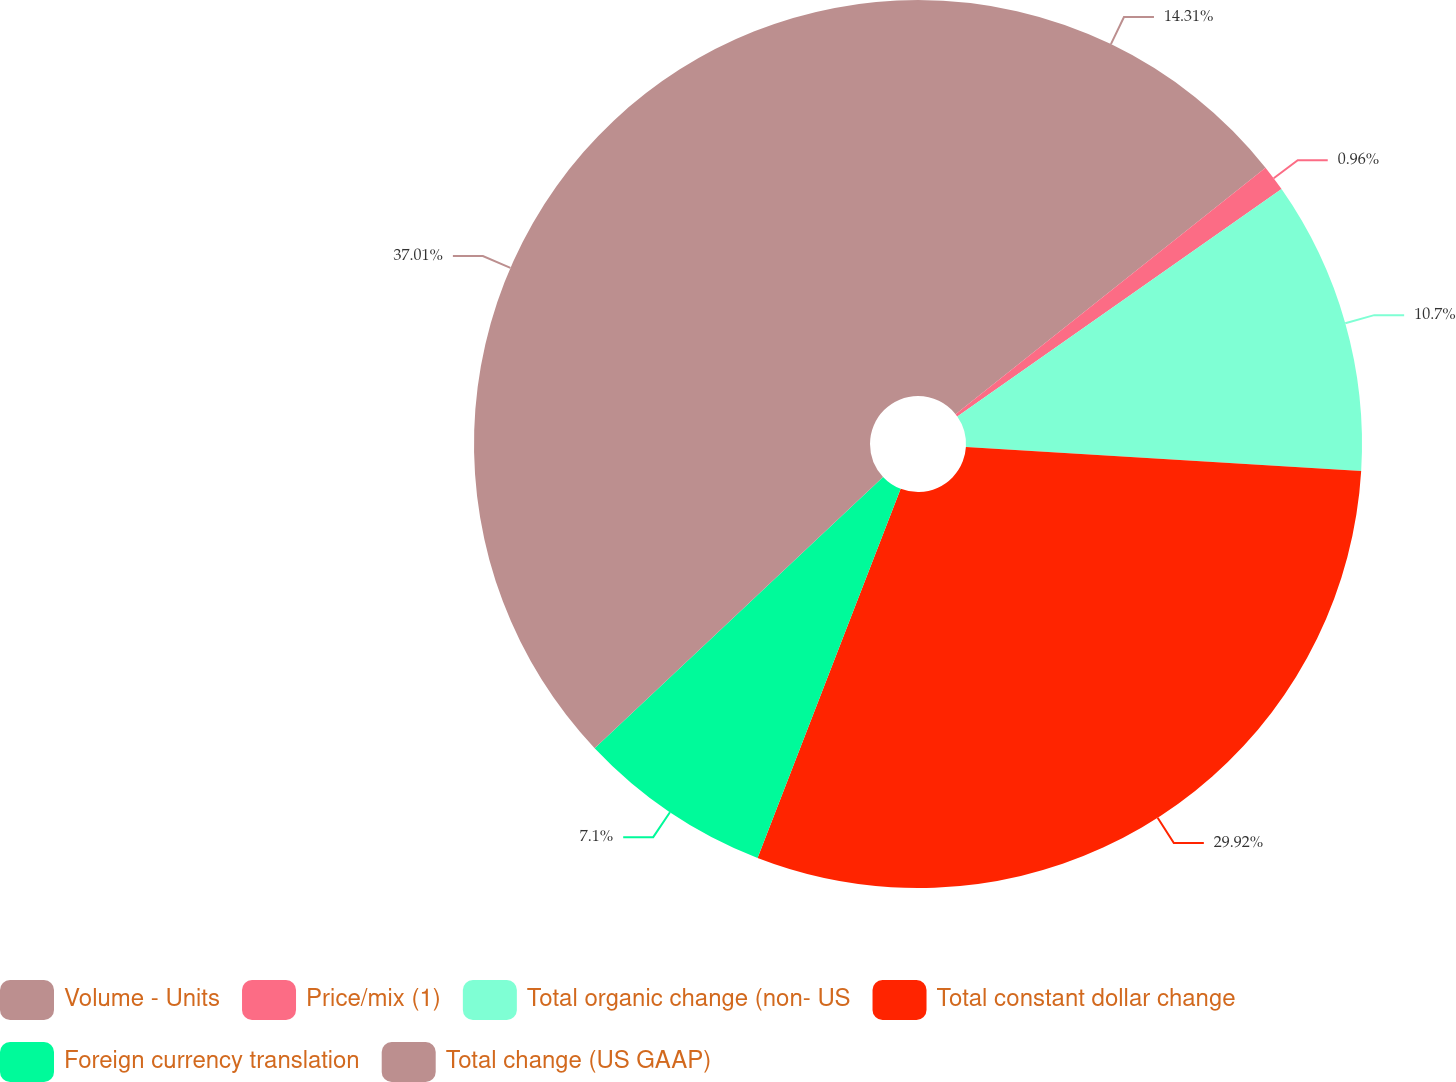<chart> <loc_0><loc_0><loc_500><loc_500><pie_chart><fcel>Volume - Units<fcel>Price/mix (1)<fcel>Total organic change (non- US<fcel>Total constant dollar change<fcel>Foreign currency translation<fcel>Total change (US GAAP)<nl><fcel>14.31%<fcel>0.96%<fcel>10.7%<fcel>29.92%<fcel>7.1%<fcel>37.02%<nl></chart> 